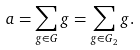<formula> <loc_0><loc_0><loc_500><loc_500>a = \sum _ { g \in G } g = \sum _ { g \in G _ { 2 } } g .</formula> 